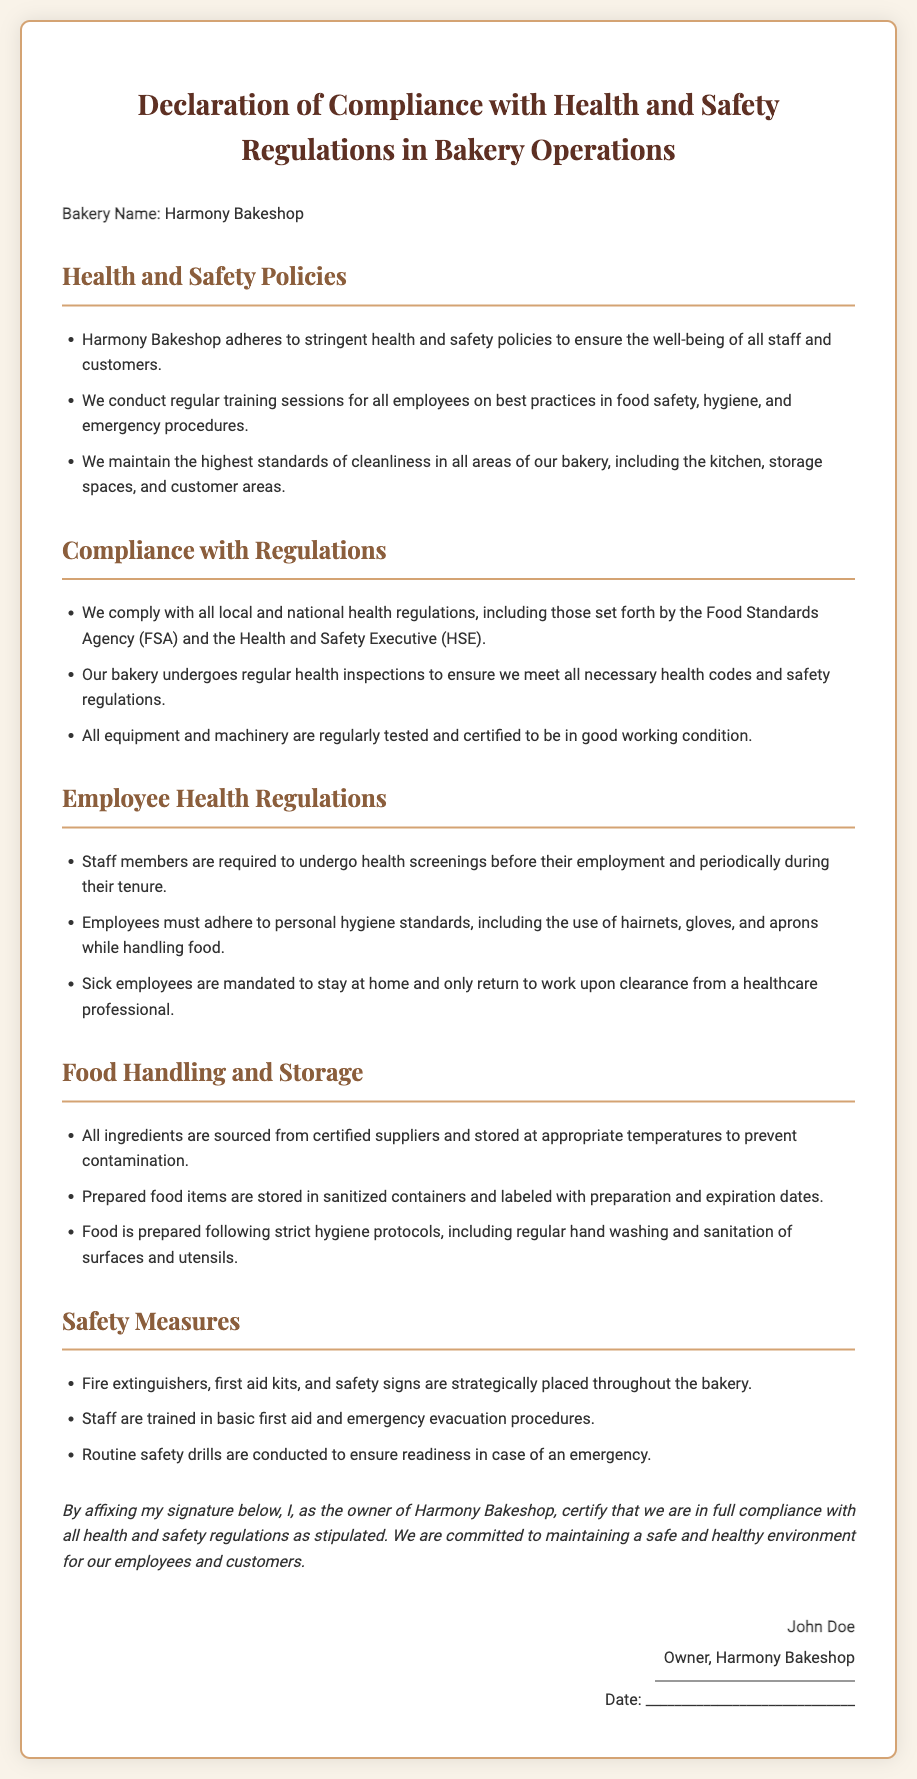What is the name of the bakery? The name of the bakery is stated at the top of the document.
Answer: Harmony Bakeshop Who is the owner of the bakery? The owner's name is mentioned in the signature section of the document.
Answer: John Doe What regulatory agency does the bakery comply with? The document lists the regulatory agencies in the compliance section.
Answer: Food Standards Agency What is the purpose of employee health screenings? The reason for the screenings is stated under employee health regulations.
Answer: Health safety What items are required to be stored at appropriate temperatures? The document specifies what needs to be stored properly in the food handling section.
Answer: Ingredients How often do health inspections occur? The frequency of inspections can be inferred from the compliance section stating they occur regularly.
Answer: Regularly What first aid training is provided to staff? The document notes the training provided in the safety measures section.
Answer: Basic first aid What is the significance of the signature on the document? The signature certifies compliance with health and safety regulations.
Answer: Certification of compliance 